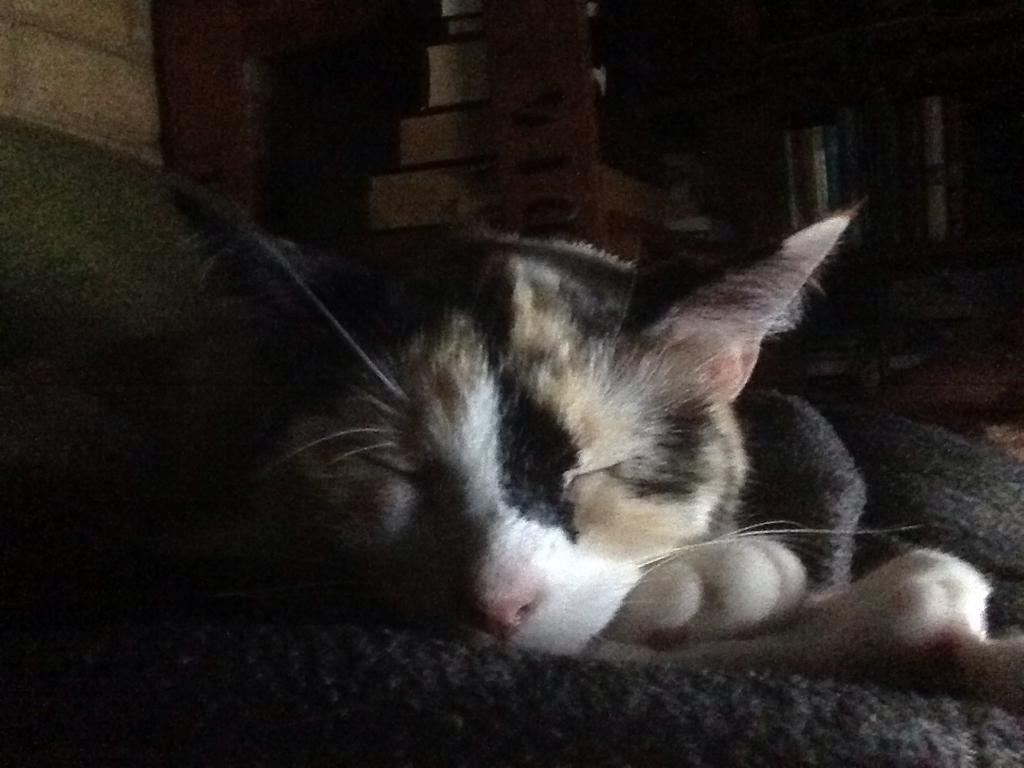Could you give a brief overview of what you see in this image? In this image there is a cat laying on a mat, in the background it is dark. 